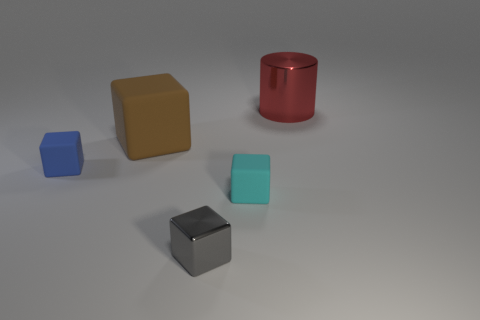Subtract all brown cylinders. Subtract all cyan blocks. How many cylinders are left? 1 Add 5 tiny gray metallic cubes. How many objects exist? 10 Subtract all cylinders. How many objects are left? 4 Subtract all cyan matte objects. Subtract all tiny green cylinders. How many objects are left? 4 Add 4 brown cubes. How many brown cubes are left? 5 Add 2 tiny yellow balls. How many tiny yellow balls exist? 2 Subtract 0 red spheres. How many objects are left? 5 